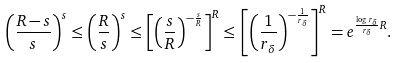Convert formula to latex. <formula><loc_0><loc_0><loc_500><loc_500>\left ( \frac { R - s } { s } \right ) ^ { s } \leq \left ( \frac { R } { s } \right ) ^ { s } \leq \left [ \left ( \frac { s } { R } \right ) ^ { - \frac { s } { R } } \right ] ^ { R } \leq \left [ \left ( \frac { 1 } { r _ { \delta } } \right ) ^ { - \frac { 1 } { r _ { \delta } } } \right ] ^ { R } = e ^ { \frac { \log r _ { \delta } } { r _ { \delta } } R } .</formula> 